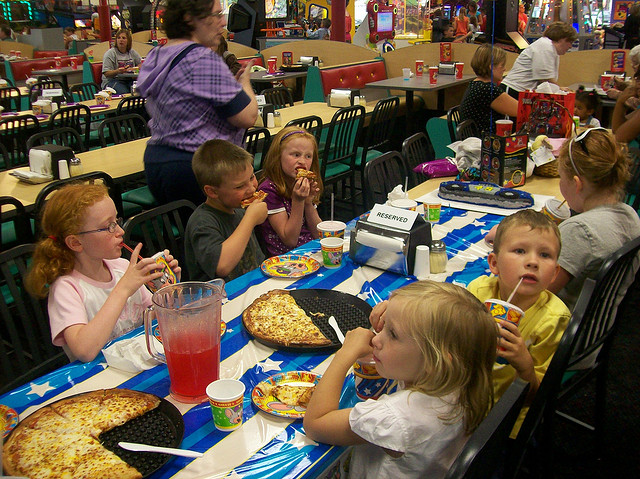Please identify all text content in this image. RESENVEO 